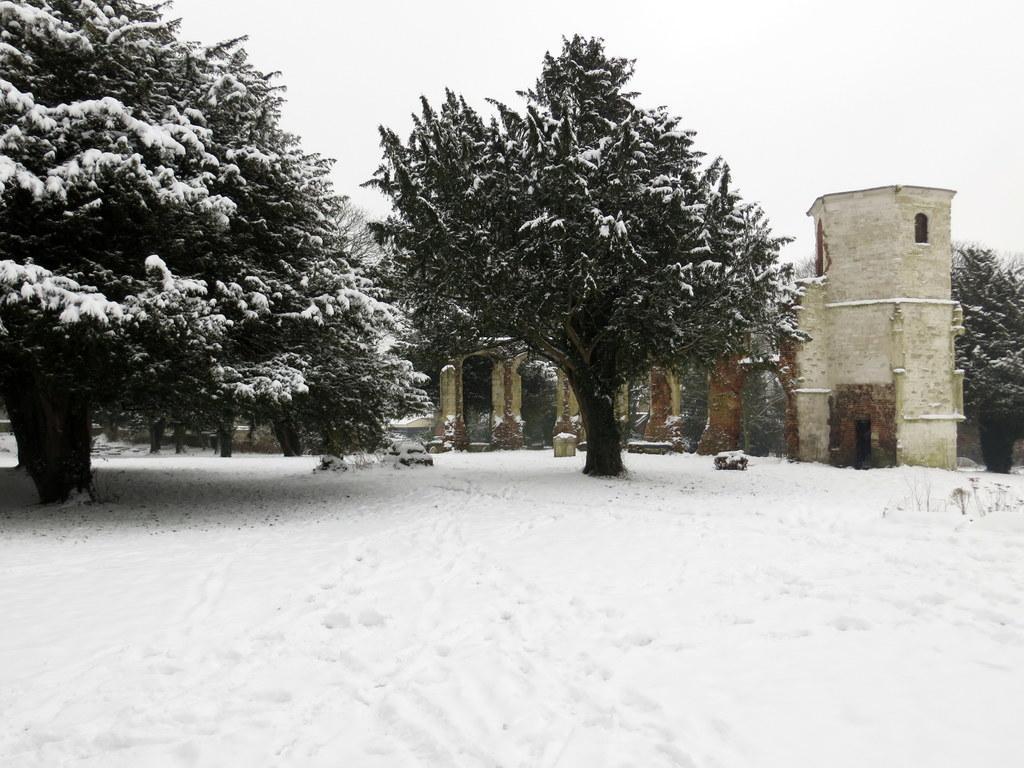In one or two sentences, can you explain what this image depicts? In this image we can see the building and also the trees. We can also see the snow. Sky is also visible in this image. 